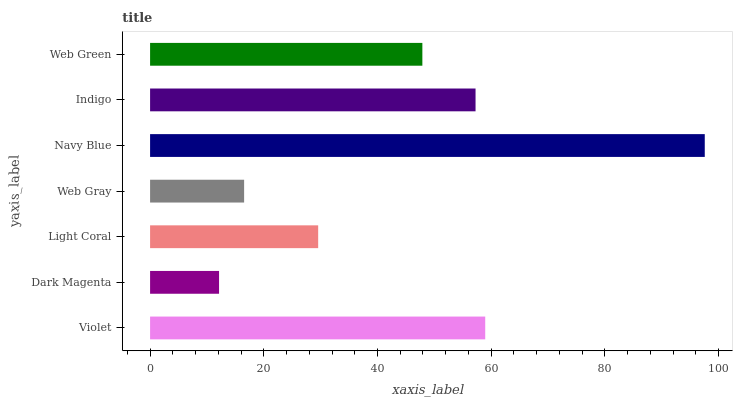Is Dark Magenta the minimum?
Answer yes or no. Yes. Is Navy Blue the maximum?
Answer yes or no. Yes. Is Light Coral the minimum?
Answer yes or no. No. Is Light Coral the maximum?
Answer yes or no. No. Is Light Coral greater than Dark Magenta?
Answer yes or no. Yes. Is Dark Magenta less than Light Coral?
Answer yes or no. Yes. Is Dark Magenta greater than Light Coral?
Answer yes or no. No. Is Light Coral less than Dark Magenta?
Answer yes or no. No. Is Web Green the high median?
Answer yes or no. Yes. Is Web Green the low median?
Answer yes or no. Yes. Is Light Coral the high median?
Answer yes or no. No. Is Web Gray the low median?
Answer yes or no. No. 